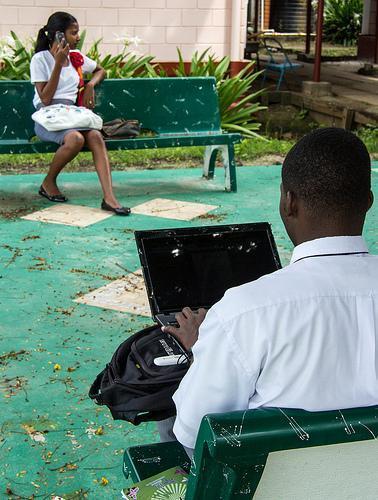How many people are there?
Give a very brief answer. 2. How many laptops are visible in this photo?
Give a very brief answer. 1. How many people are reading book?
Give a very brief answer. 0. 